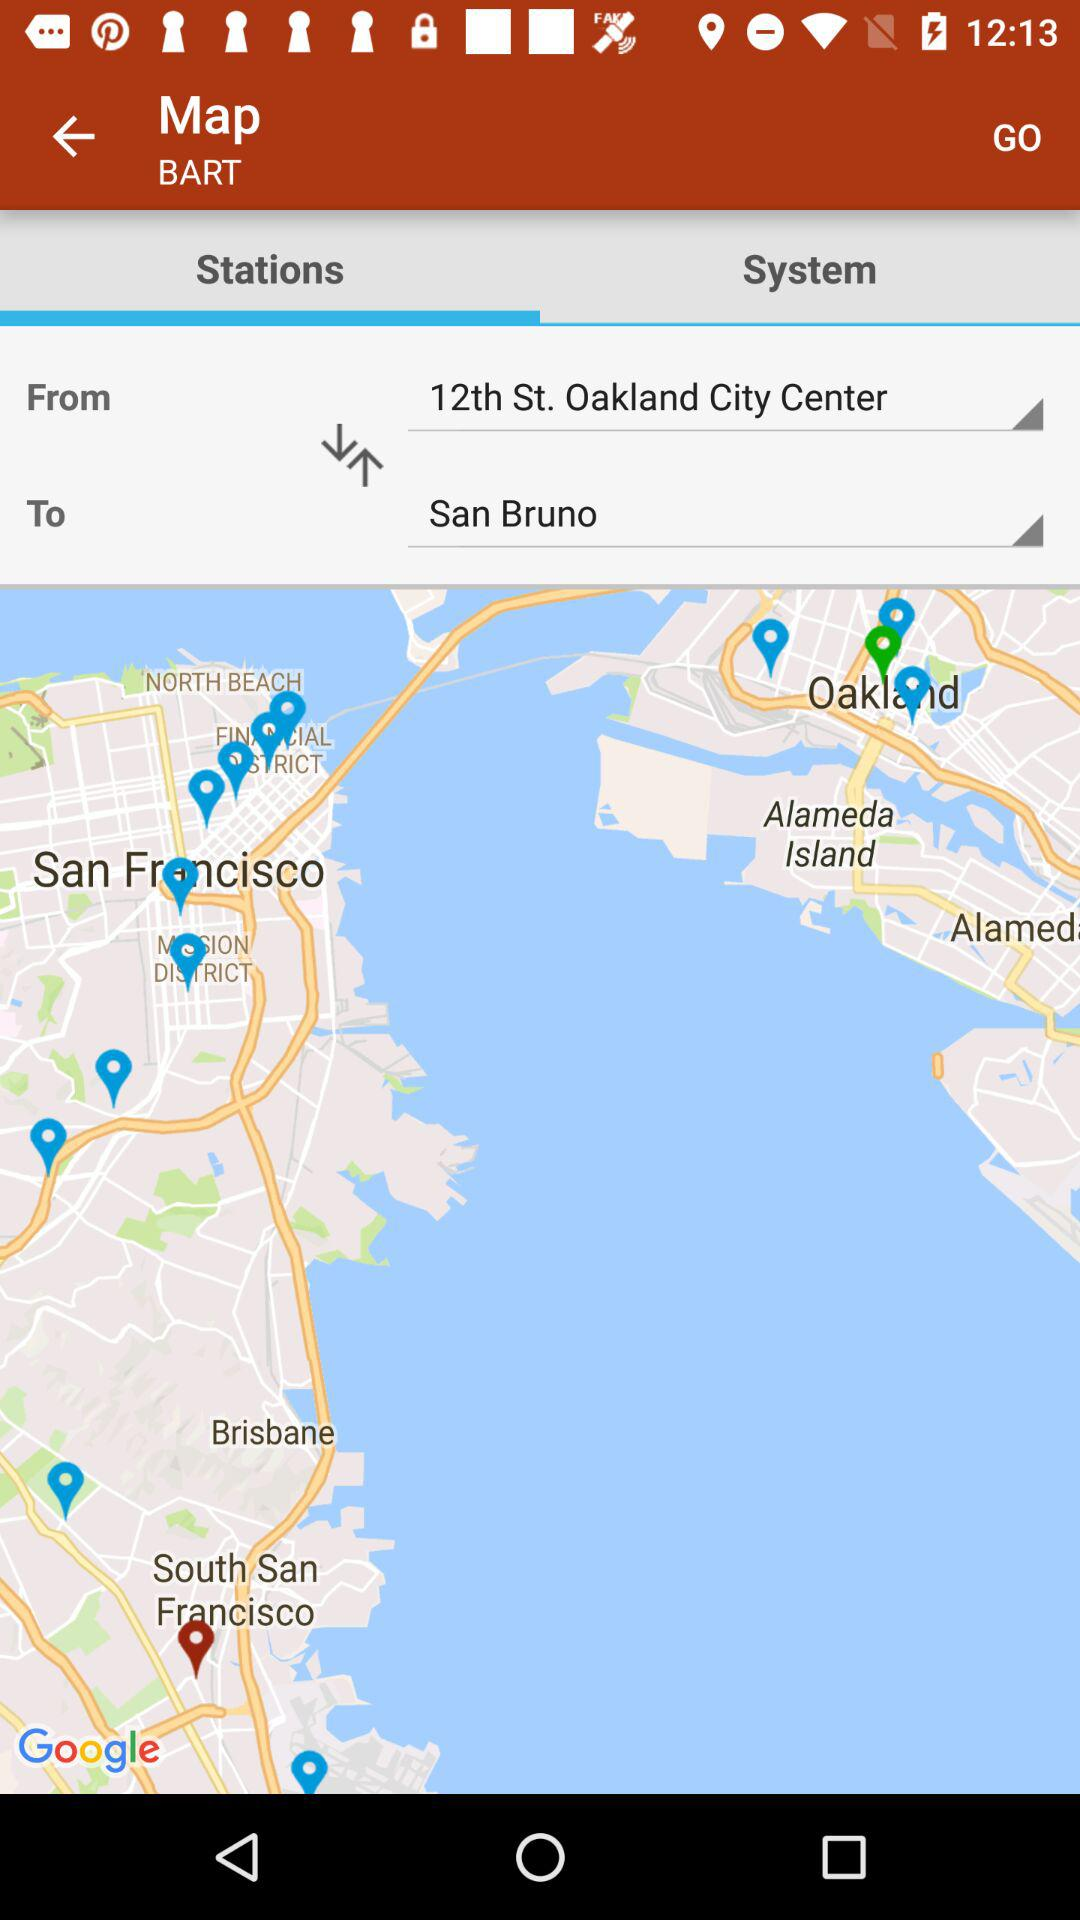What is the destination? The destination is San Bruno. 